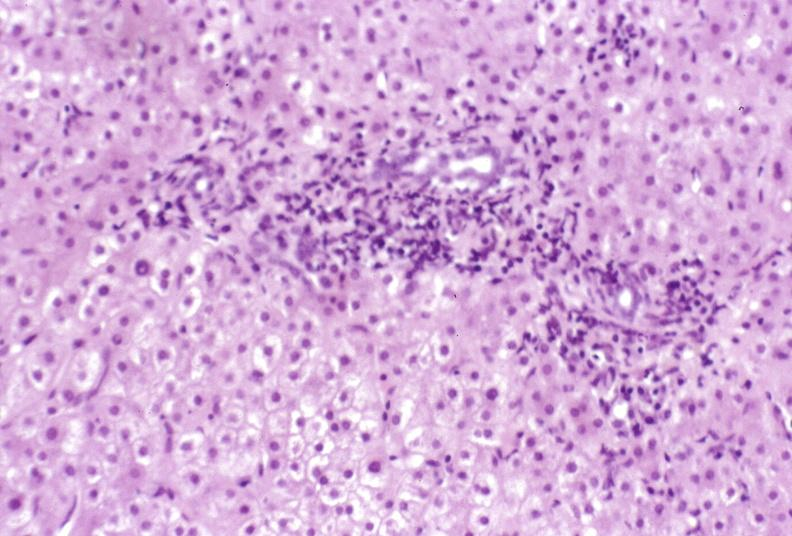s liver present?
Answer the question using a single word or phrase. Yes 